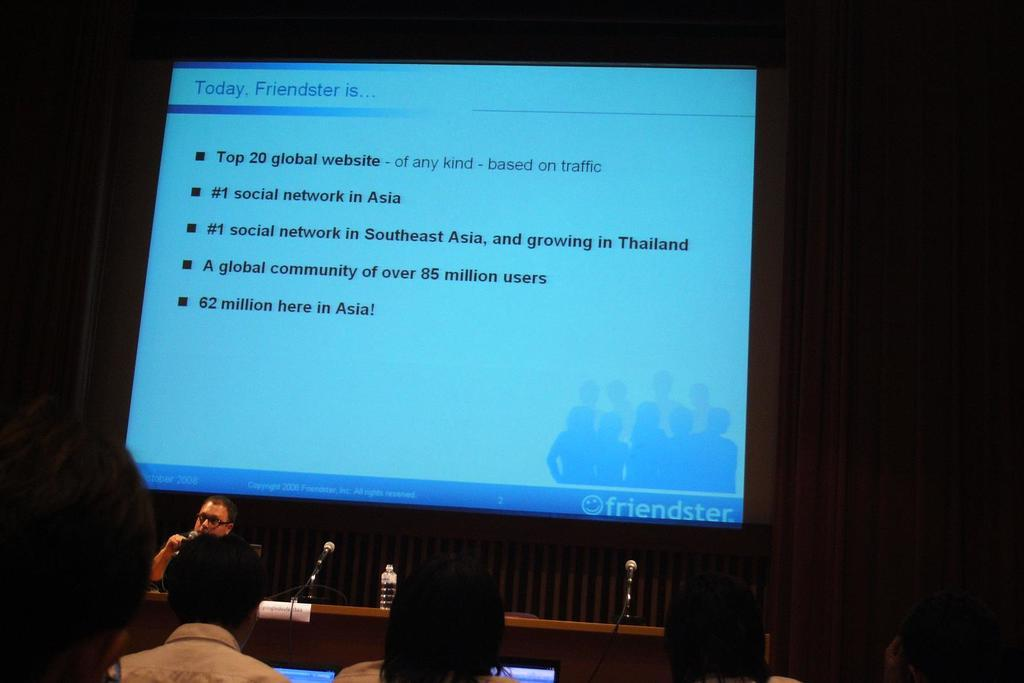What are the people in the image doing? The people in the image are sitting. What is on the table in the image? There is a table in the image with a bottle and microphones (mikes) on it. What can be seen on the screen in the image? There is a screen with a display in the image. How would you describe the lighting in the image? The background of the image appears dark. Can you tell me what the goose is saying through the microphone in the image? There is no goose present in the image, and therefore no such statement can be heard. What type of tiger can be seen interacting with the people in the image? There is no tiger present in the image; only people, a table, a bottle, microphones, and a screen are visible. 